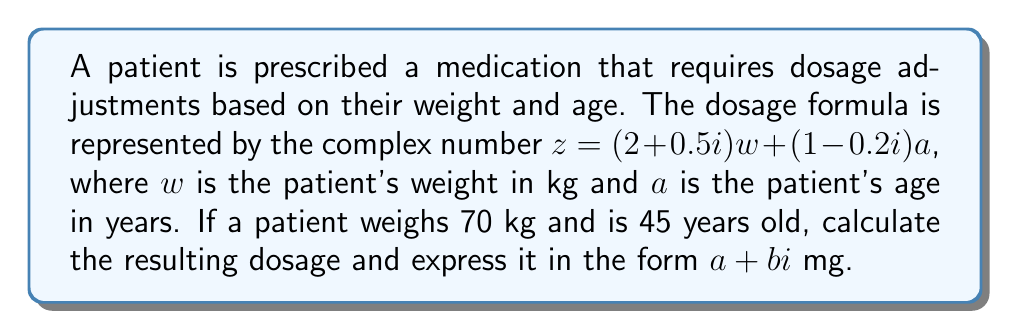Help me with this question. To solve this problem, we'll follow these steps:

1) We're given the formula: $z = (2 + 0.5i)w + (1 - 0.2i)a$

2) Substitute the values:
   $w = 70$ (weight in kg)
   $a = 45$ (age in years)

3) Let's calculate each part separately:

   For weight: $(2 + 0.5i)w = (2 + 0.5i)(70) = 140 + 35i$

   For age: $(1 - 0.2i)a = (1 - 0.2i)(45) = 45 - 9i$

4) Now, add these two complex numbers:

   $z = (140 + 35i) + (45 - 9i)$

5) Combine like terms:

   $z = (140 + 45) + (35 - 9)i$
   $z = 185 + 26i$

6) Therefore, the resulting dosage is $185 + 26i$ mg.
Answer: $185 + 26i$ mg 